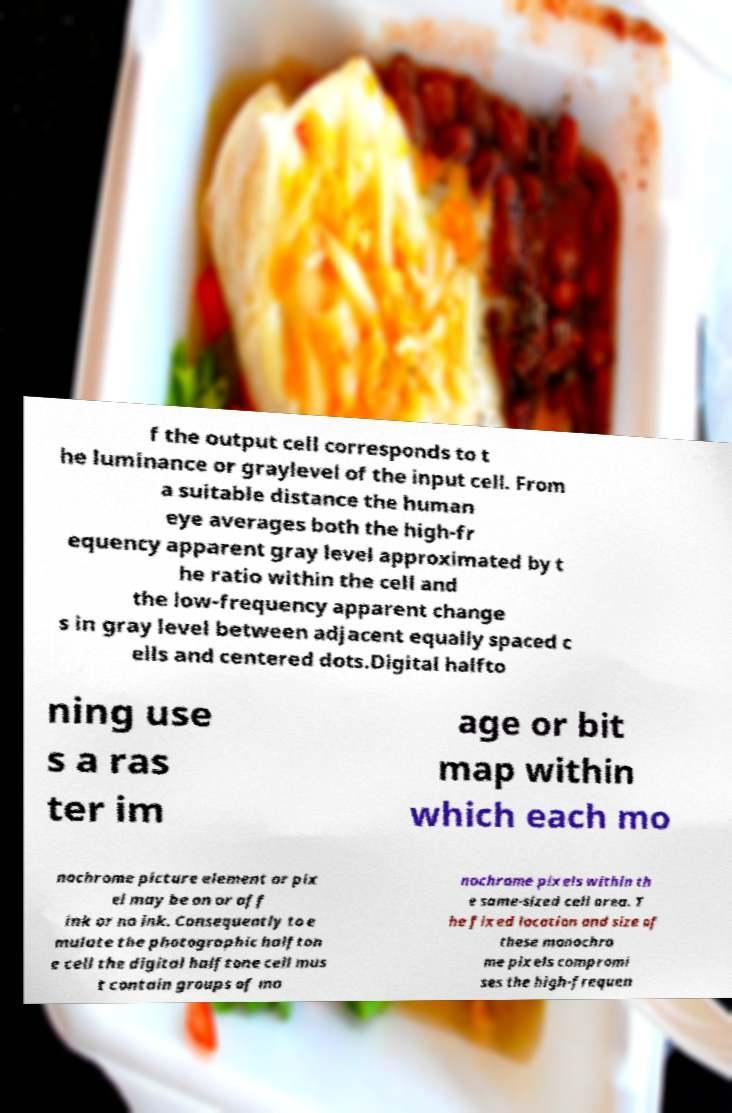Can you read and provide the text displayed in the image?This photo seems to have some interesting text. Can you extract and type it out for me? f the output cell corresponds to t he luminance or graylevel of the input cell. From a suitable distance the human eye averages both the high-fr equency apparent gray level approximated by t he ratio within the cell and the low-frequency apparent change s in gray level between adjacent equally spaced c ells and centered dots.Digital halfto ning use s a ras ter im age or bit map within which each mo nochrome picture element or pix el may be on or off ink or no ink. Consequently to e mulate the photographic halfton e cell the digital halftone cell mus t contain groups of mo nochrome pixels within th e same-sized cell area. T he fixed location and size of these monochro me pixels compromi ses the high-frequen 